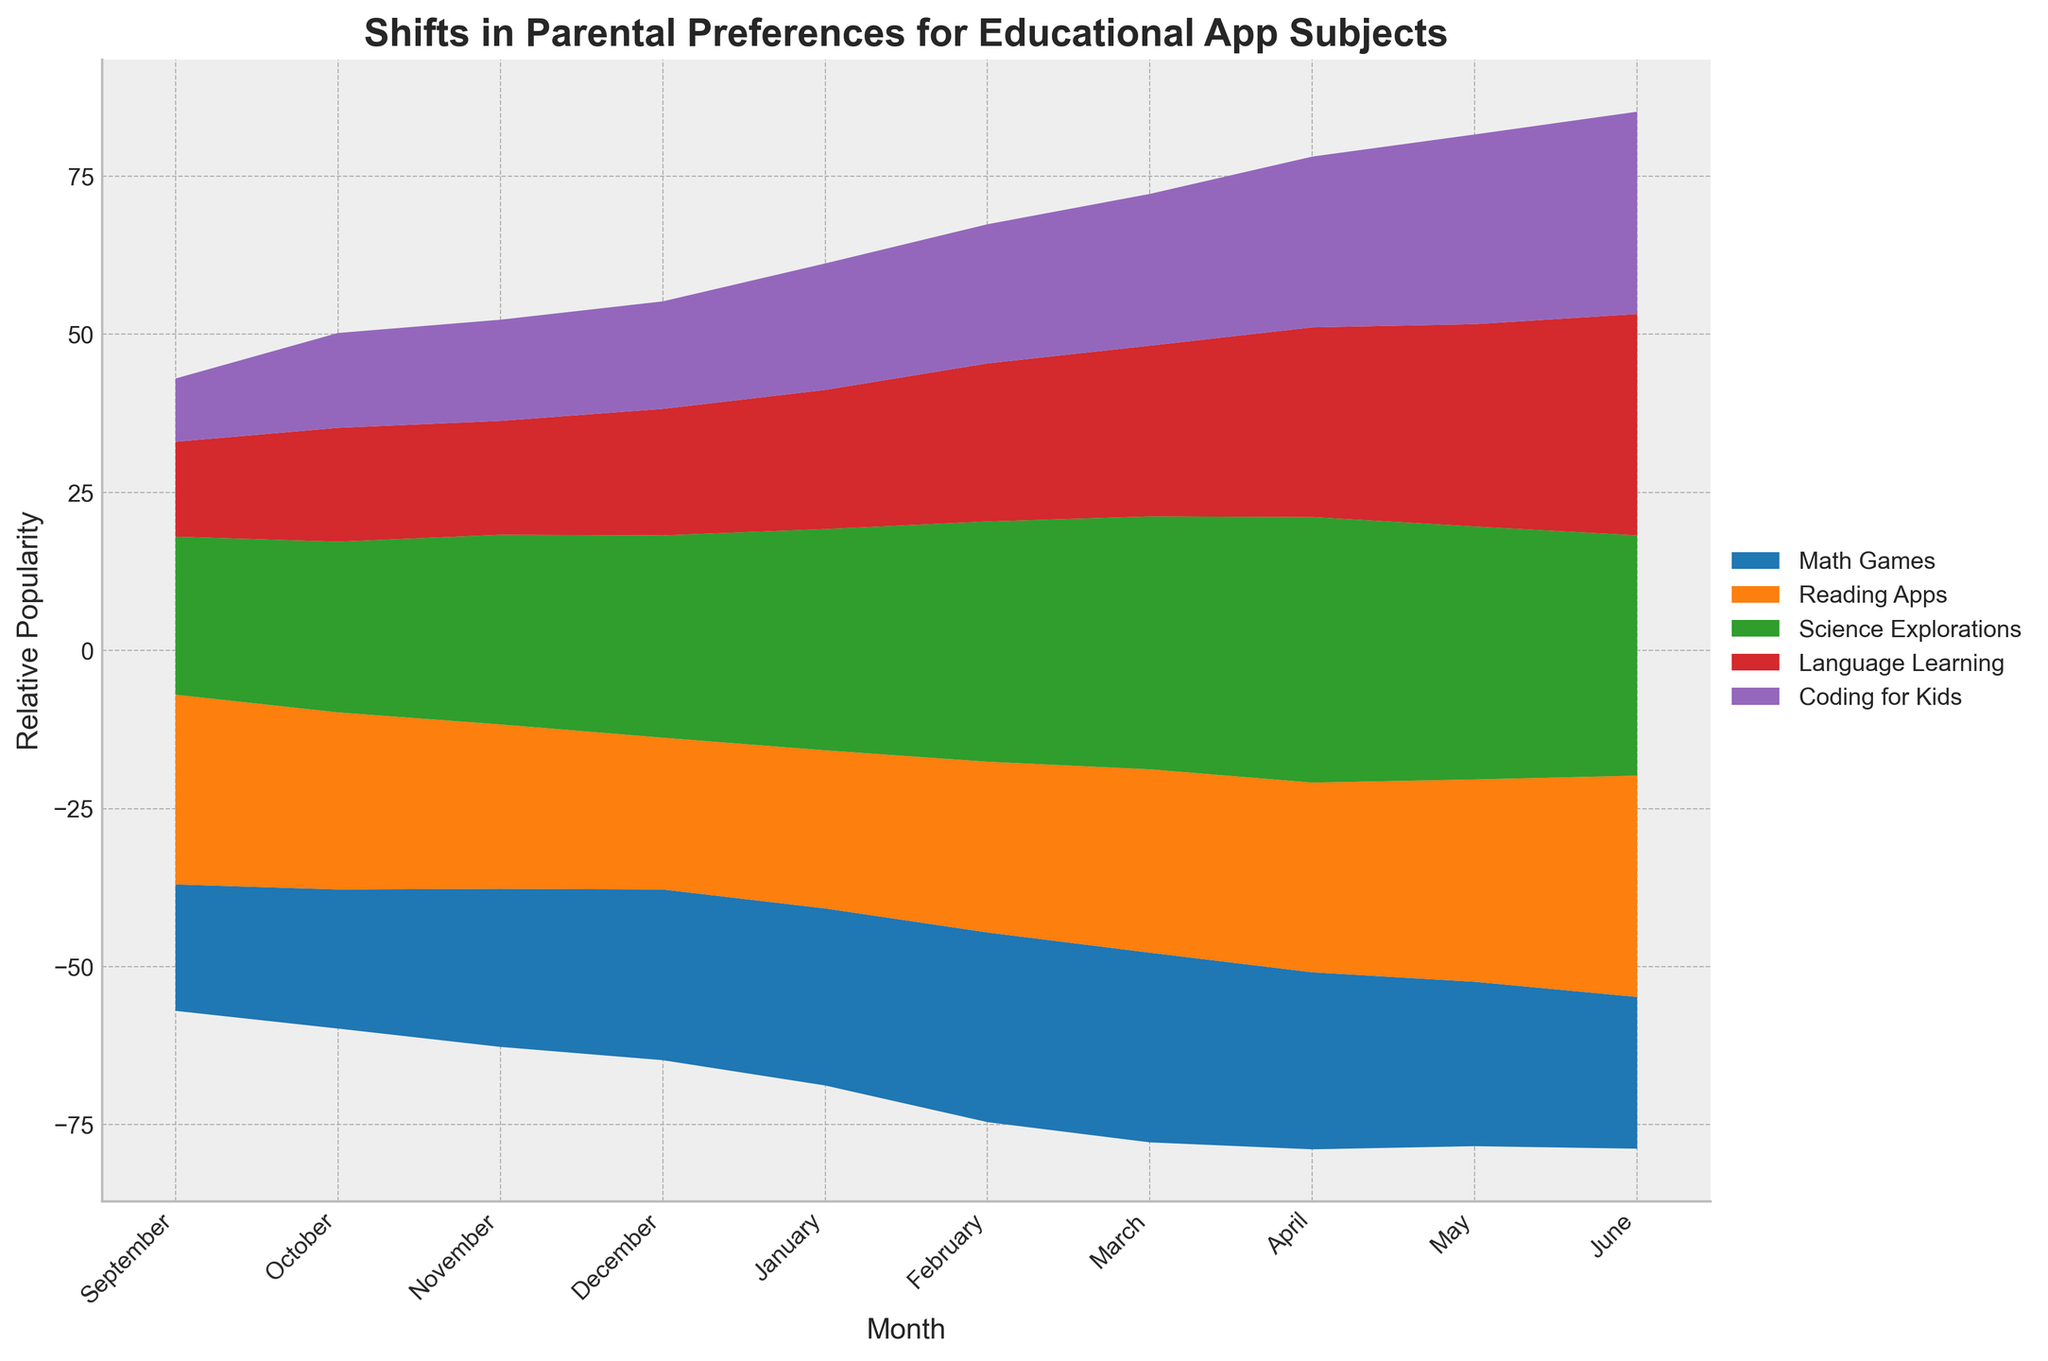What is the title of the figure? The title of the figure is usually located at the top and provides an overview of what the figure is about. In this case, it is "Shifts in Parental Preferences for Educational App Subjects".
Answer: Shifts in Parental Preferences for Educational App Subjects What are the subjects represented in the figure? The subjects are usually indicated in the legend and used to differentiate the different areas in the Stream graph. The subjects in this figure are Math Games, Reading Apps, Science Explorations, Language Learning, and Coding for Kids.
Answer: Math Games, Reading Apps, Science Explorations, Language Learning, Coding for Kids Which subject had the highest relative popularity in June? To determine the highest relative popularity, observe the peaks of the areas in the Stream graph for the month of June. The area representing Language Learning is the largest in June.
Answer: Language Learning How did the popularity of Coding for Kids change from January to May? Compare the size of the Coding for Kids area between January and May. The area increased from January's smaller size to become significantly larger by May. This shows an increase in popularity.
Answer: Increased Which month shows a peak in popularity for Science Explorations? Look for the highest peak in the area representing Science Explorations within the Stream graph. The month with the highest peak is April.
Answer: April What is the trend in the relative popularity of Reading Apps from September to June? Analyze the shape and shifts of the area representing Reading Apps over the course of the months. The area generally increases from September to June, indicating a rising trend in popularity.
Answer: Rising Compare the relative popularity of Math Games and Coding for Kids in December. Compare the size of the areas representing Math Games and Coding for Kids during December. Math Games has a significantly larger area than Coding for Kids.
Answer: Math Games is more popular What happens to the relative popularity of Language Learning from March to June? Observe the changes in the area for Language Learning from March through June. The relative popularity steadily increases over these months.
Answer: Steadily increases Did any subject see a decline in popularity from May to June? Evaluate the size of each subject's area from May to June. Math Games is the only subject that shows a decrease in area size, indicating a decline in popularity.
Answer: Math Games How did the popularity trend for Reading Apps change in the first three months? Evaluate the Reading Apps area from September to November. The area decreases from September to October and then slightly increases from October to November.
Answer: Decreased then increased 